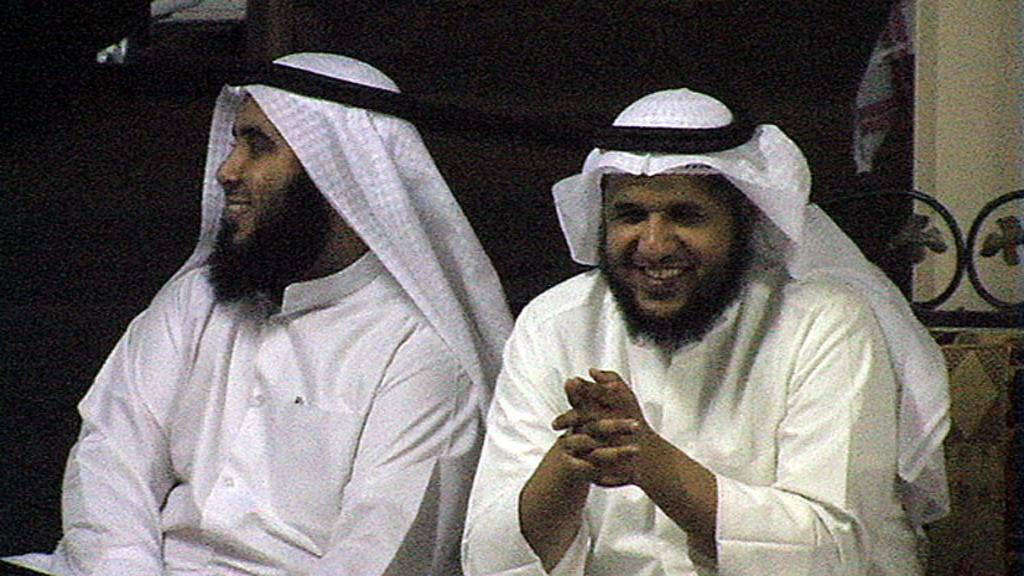How many people are in the image? There are two men in the image. What are the men doing in the image? The men are sitting on a couch. What are the men wearing in the image? The men are wearing white dresses. Can you describe the background of the image? The background of the image is not clear. What addition can be seen in the image, other than the two men sitting on the couch? There is no additional object or element mentioned in the provided facts. The image only features two men sitting on a couch, and their clothing (white dresses). 